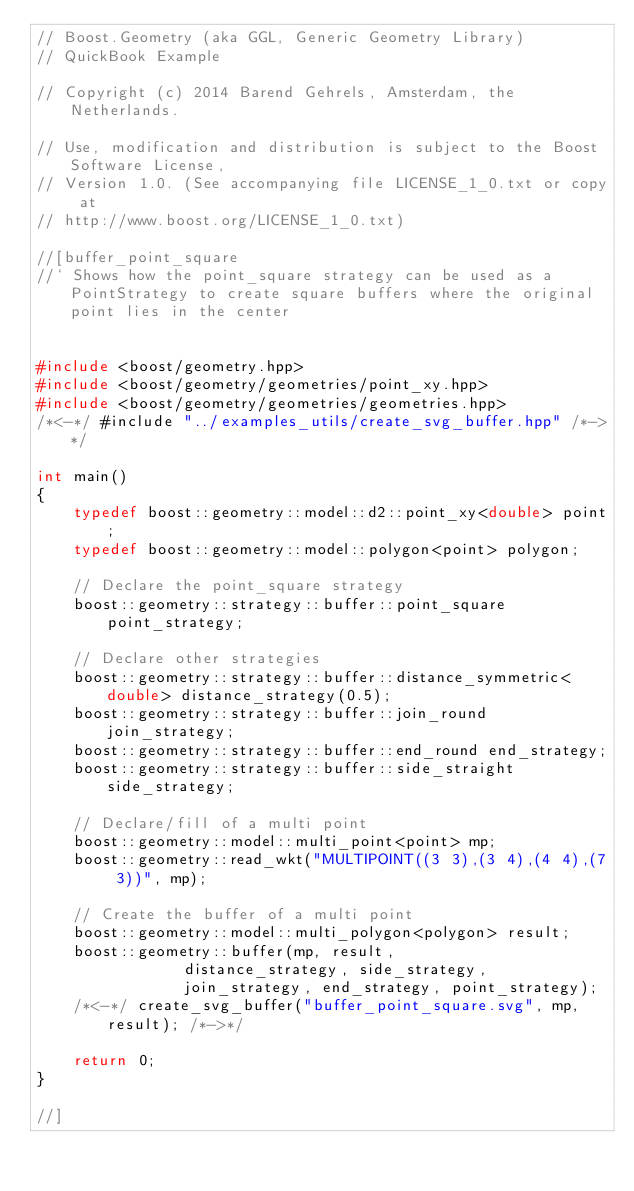<code> <loc_0><loc_0><loc_500><loc_500><_C++_>// Boost.Geometry (aka GGL, Generic Geometry Library)
// QuickBook Example

// Copyright (c) 2014 Barend Gehrels, Amsterdam, the Netherlands.

// Use, modification and distribution is subject to the Boost Software License,
// Version 1.0. (See accompanying file LICENSE_1_0.txt or copy at
// http://www.boost.org/LICENSE_1_0.txt)

//[buffer_point_square
//` Shows how the point_square strategy can be used as a PointStrategy to create square buffers where the original point lies in the center


#include <boost/geometry.hpp>
#include <boost/geometry/geometries/point_xy.hpp>
#include <boost/geometry/geometries/geometries.hpp>
/*<-*/ #include "../examples_utils/create_svg_buffer.hpp" /*->*/

int main()
{
    typedef boost::geometry::model::d2::point_xy<double> point;
    typedef boost::geometry::model::polygon<point> polygon;

    // Declare the point_square strategy
    boost::geometry::strategy::buffer::point_square point_strategy;

    // Declare other strategies
    boost::geometry::strategy::buffer::distance_symmetric<double> distance_strategy(0.5);
    boost::geometry::strategy::buffer::join_round join_strategy;
    boost::geometry::strategy::buffer::end_round end_strategy;
    boost::geometry::strategy::buffer::side_straight side_strategy;

    // Declare/fill of a multi point
    boost::geometry::model::multi_point<point> mp;
    boost::geometry::read_wkt("MULTIPOINT((3 3),(3 4),(4 4),(7 3))", mp);

    // Create the buffer of a multi point
    boost::geometry::model::multi_polygon<polygon> result;
    boost::geometry::buffer(mp, result,
                distance_strategy, side_strategy,
                join_strategy, end_strategy, point_strategy);
    /*<-*/ create_svg_buffer("buffer_point_square.svg", mp, result); /*->*/

    return 0;
}

//]

</code> 